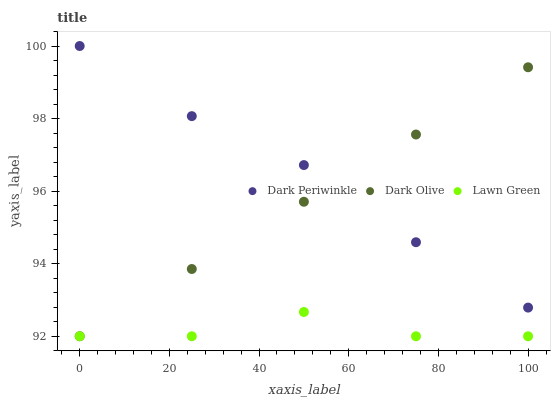Does Lawn Green have the minimum area under the curve?
Answer yes or no. Yes. Does Dark Periwinkle have the maximum area under the curve?
Answer yes or no. Yes. Does Dark Olive have the minimum area under the curve?
Answer yes or no. No. Does Dark Olive have the maximum area under the curve?
Answer yes or no. No. Is Dark Olive the smoothest?
Answer yes or no. Yes. Is Lawn Green the roughest?
Answer yes or no. Yes. Is Dark Periwinkle the smoothest?
Answer yes or no. No. Is Dark Periwinkle the roughest?
Answer yes or no. No. Does Lawn Green have the lowest value?
Answer yes or no. Yes. Does Dark Periwinkle have the lowest value?
Answer yes or no. No. Does Dark Periwinkle have the highest value?
Answer yes or no. Yes. Does Dark Olive have the highest value?
Answer yes or no. No. Is Lawn Green less than Dark Periwinkle?
Answer yes or no. Yes. Is Dark Periwinkle greater than Lawn Green?
Answer yes or no. Yes. Does Dark Olive intersect Dark Periwinkle?
Answer yes or no. Yes. Is Dark Olive less than Dark Periwinkle?
Answer yes or no. No. Is Dark Olive greater than Dark Periwinkle?
Answer yes or no. No. Does Lawn Green intersect Dark Periwinkle?
Answer yes or no. No. 